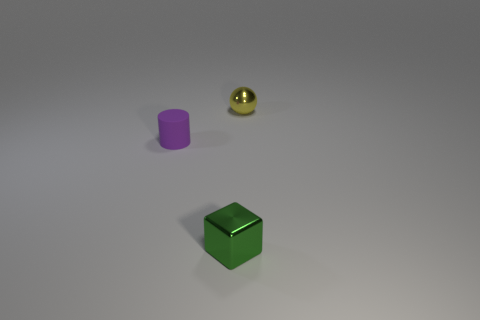Add 2 cubes. How many objects exist? 5 Subtract all cylinders. How many objects are left? 2 Subtract all green blocks. Subtract all yellow metal objects. How many objects are left? 1 Add 1 cylinders. How many cylinders are left? 2 Add 2 brown rubber cylinders. How many brown rubber cylinders exist? 2 Subtract 0 yellow cubes. How many objects are left? 3 